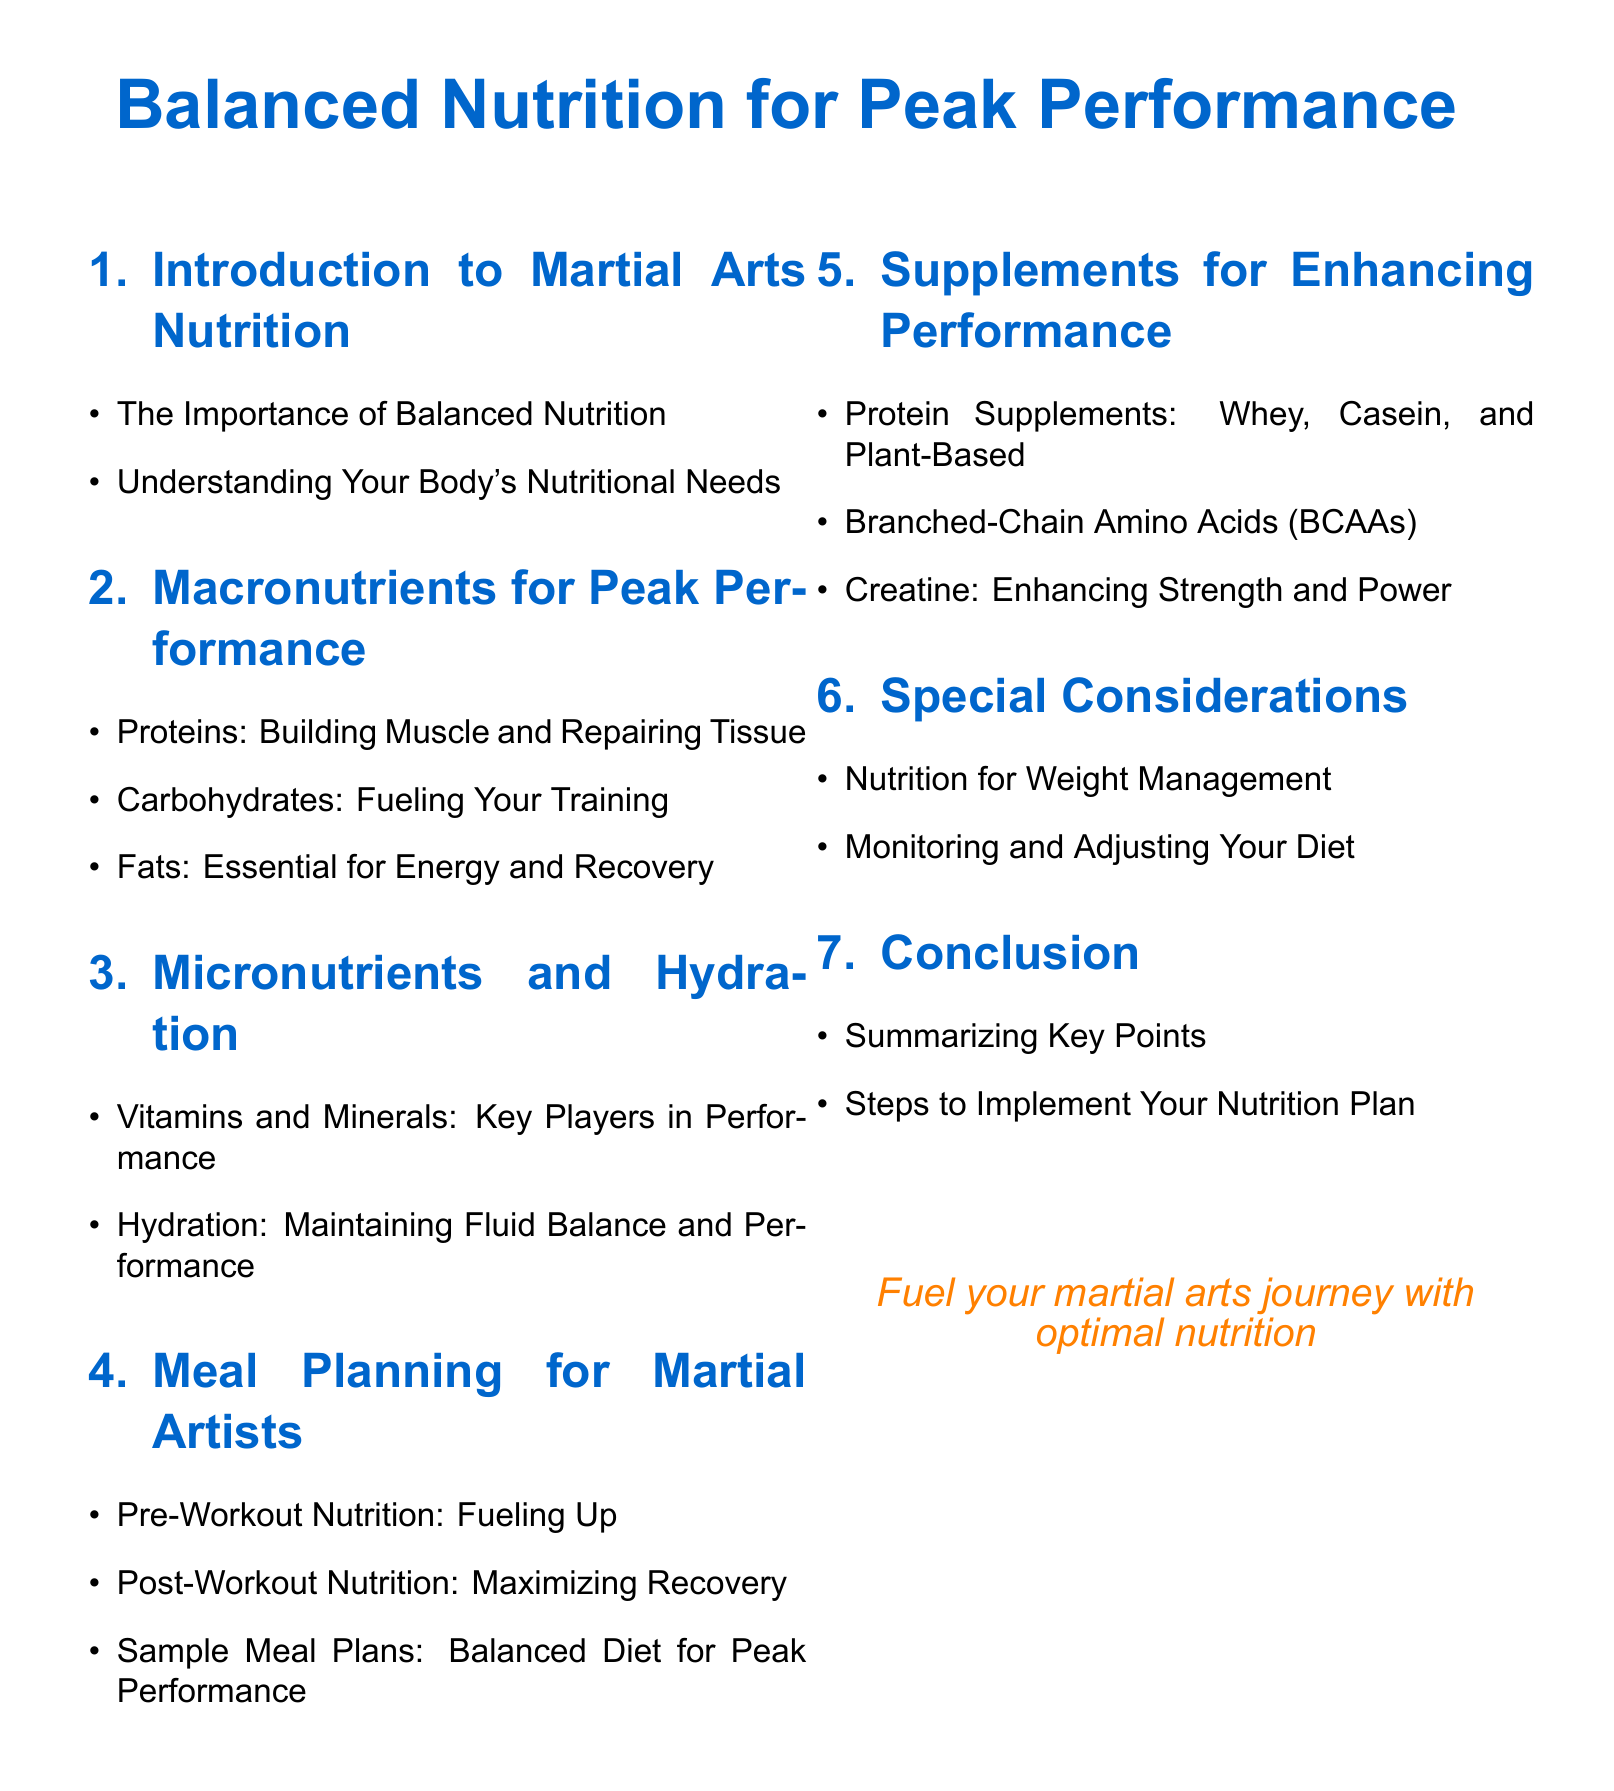What is the title of the document? The title of the document is the main focus of the content, which is indicated at the top.
Answer: Balanced Nutrition for Peak Performance How many sections are there in the document? The section titles indicate the different areas covered in the document, and a count shows the total sections.
Answer: 6 What nutrient is emphasized for building muscle and repairing tissue? The section on macronutrients specifically highlights a nutrient crucial for muscle development.
Answer: Proteins What is one example of a protein supplement mentioned? The section on supplements lists various types of protein supplements that can enhance performance.
Answer: Whey What is the importance of hydration in martial arts? The section describes hydration’s role in performance, reflecting its significance in sports nutrition.
Answer: Maintaining Fluid Balance and Performance What should a post-workout meal focus on? The meal planning section outlines specific nutrition goals following training to aid recovery.
Answer: Maximizing Recovery What are BCAAs known for? The supplements section lists these as crucial for enhancing performance and recovery in athletes.
Answer: Enhancing Performance What is one special consideration for athletes regarding nutrition? The special considerations section informs about specific dietary needs based on individual circumstances.
Answer: Nutrition for Weight Management 